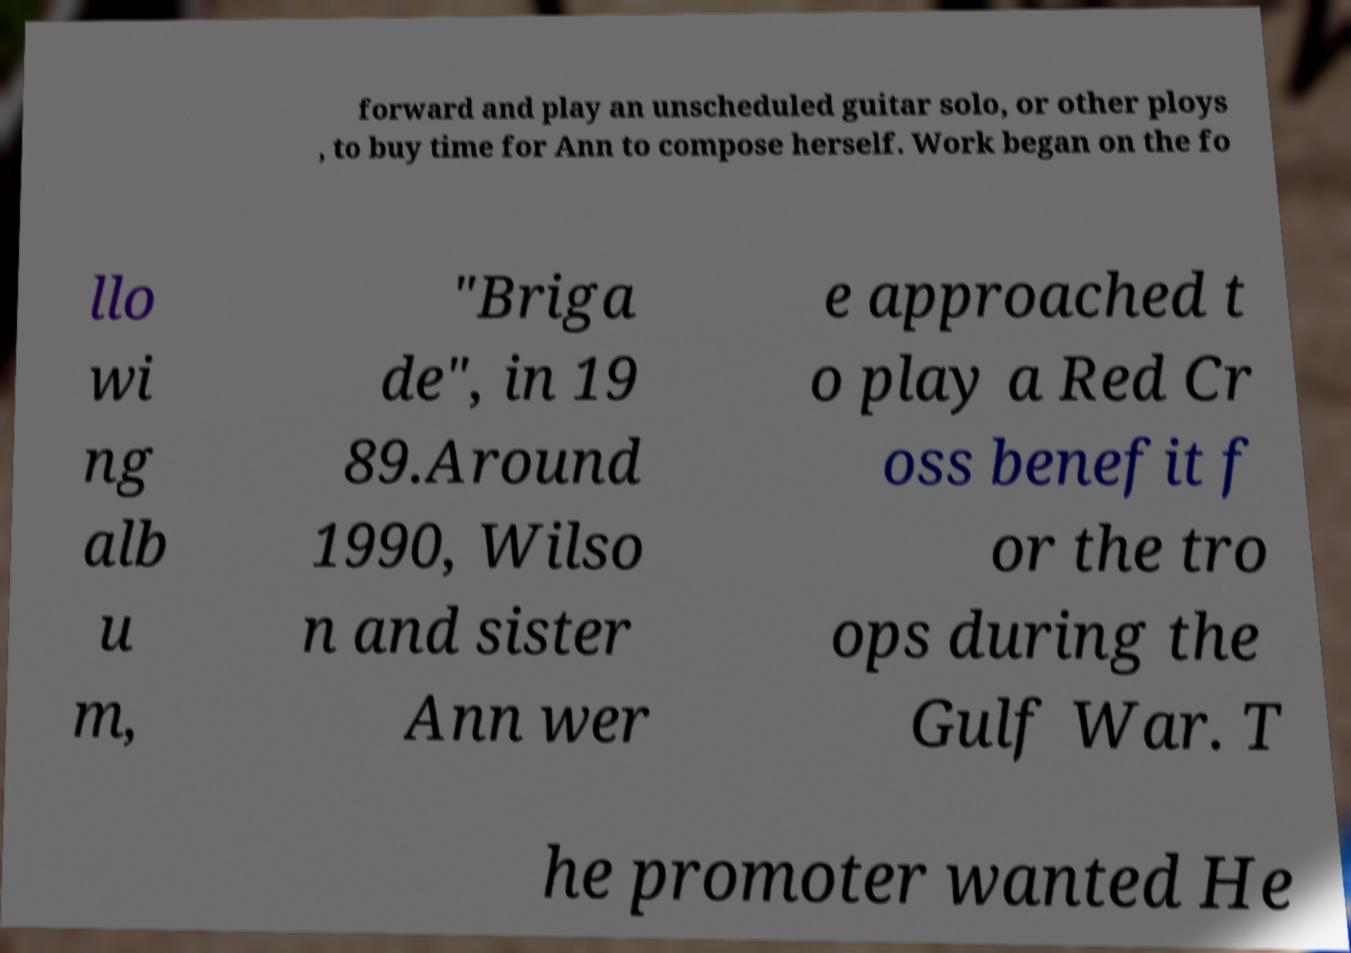Can you accurately transcribe the text from the provided image for me? forward and play an unscheduled guitar solo, or other ploys , to buy time for Ann to compose herself. Work began on the fo llo wi ng alb u m, "Briga de", in 19 89.Around 1990, Wilso n and sister Ann wer e approached t o play a Red Cr oss benefit f or the tro ops during the Gulf War. T he promoter wanted He 